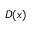<formula> <loc_0><loc_0><loc_500><loc_500>D ( x )</formula> 